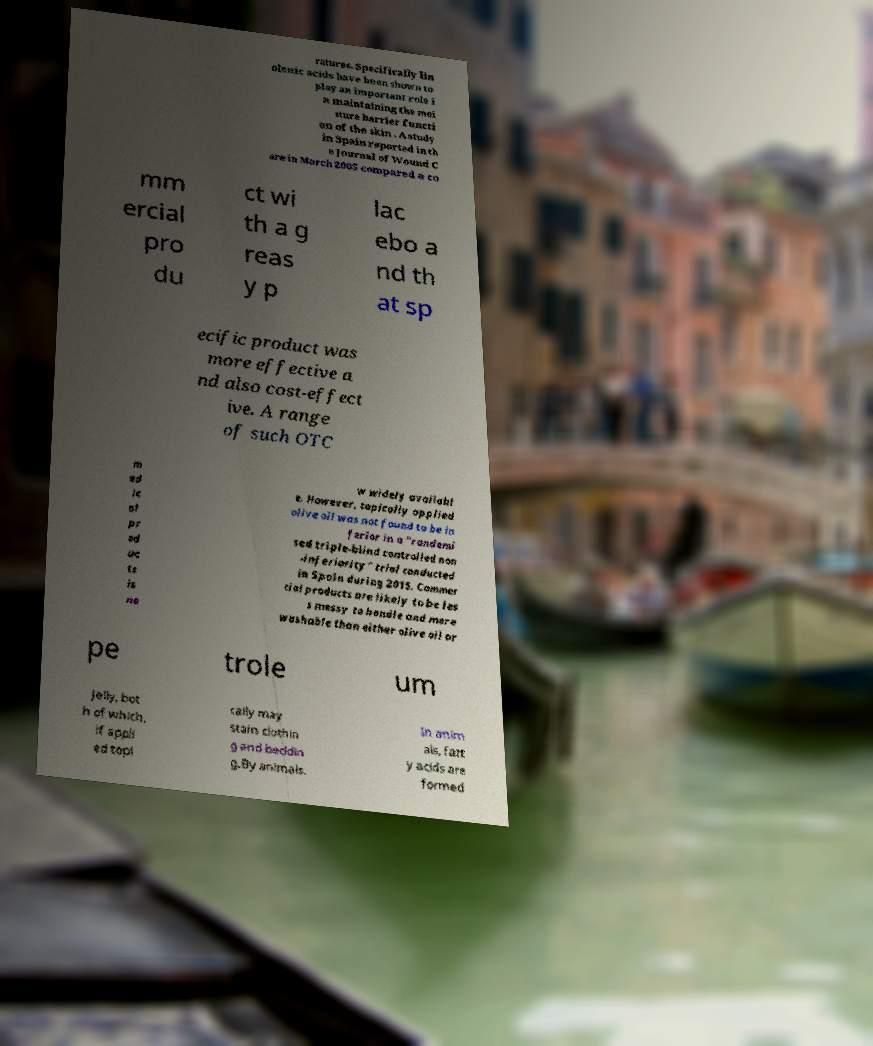What messages or text are displayed in this image? I need them in a readable, typed format. ratures. Specifically lin olenic acids have been shown to play an important role i n maintaining the moi sture barrier functi on of the skin . A study in Spain reported in th e Journal of Wound C are in March 2005 compared a co mm ercial pro du ct wi th a g reas y p lac ebo a nd th at sp ecific product was more effective a nd also cost-effect ive. A range of such OTC m ed ic al pr od uc ts is no w widely availabl e. However, topically applied olive oil was not found to be in ferior in a "randomi sed triple-blind controlled non -inferiority" trial conducted in Spain during 2015. Commer cial products are likely to be les s messy to handle and more washable than either olive oil or pe trole um jelly, bot h of which, if appli ed topi cally may stain clothin g and beddin g.By animals. In anim als, fatt y acids are formed 